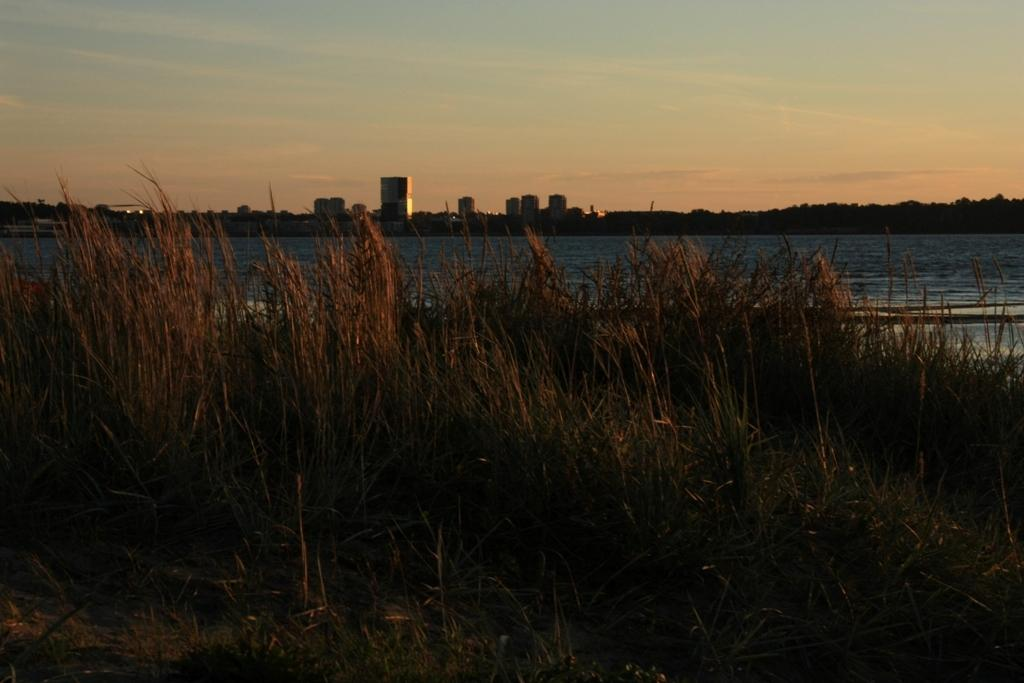What type of vegetation is present on the ground in the image? There are plants and grass on the ground in the image. What can be seen in the background of the image? There is water, buildings, and trees visible in the background. What is visible in the sky in the image? There are clouds in the sky in the image. Is there a camp visible on the slope in the image? There is no camp or slope present in the image. What phase is the moon in the image? There is no moon visible in the image; only clouds are present in the sky. 